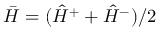<formula> <loc_0><loc_0><loc_500><loc_500>\bar { H } = ( \hat { H } ^ { + } + \hat { H } ^ { - } ) / 2</formula> 